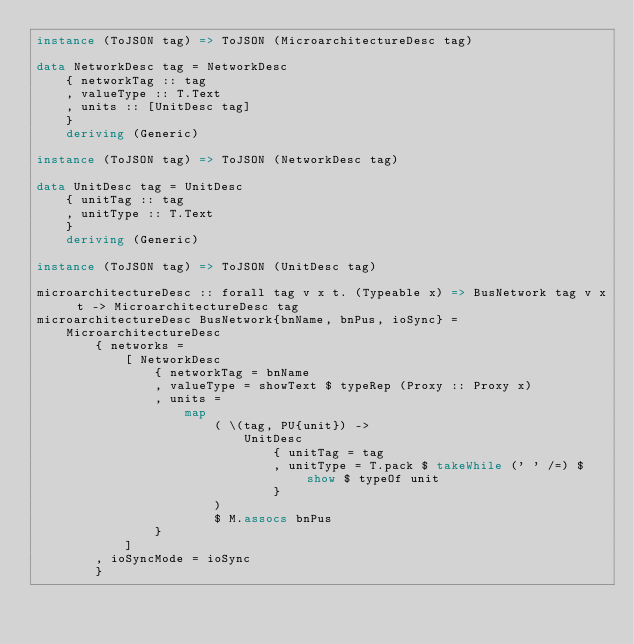<code> <loc_0><loc_0><loc_500><loc_500><_Haskell_>instance (ToJSON tag) => ToJSON (MicroarchitectureDesc tag)

data NetworkDesc tag = NetworkDesc
    { networkTag :: tag
    , valueType :: T.Text
    , units :: [UnitDesc tag]
    }
    deriving (Generic)

instance (ToJSON tag) => ToJSON (NetworkDesc tag)

data UnitDesc tag = UnitDesc
    { unitTag :: tag
    , unitType :: T.Text
    }
    deriving (Generic)

instance (ToJSON tag) => ToJSON (UnitDesc tag)

microarchitectureDesc :: forall tag v x t. (Typeable x) => BusNetwork tag v x t -> MicroarchitectureDesc tag
microarchitectureDesc BusNetwork{bnName, bnPus, ioSync} =
    MicroarchitectureDesc
        { networks =
            [ NetworkDesc
                { networkTag = bnName
                , valueType = showText $ typeRep (Proxy :: Proxy x)
                , units =
                    map
                        ( \(tag, PU{unit}) ->
                            UnitDesc
                                { unitTag = tag
                                , unitType = T.pack $ takeWhile (' ' /=) $ show $ typeOf unit
                                }
                        )
                        $ M.assocs bnPus
                }
            ]
        , ioSyncMode = ioSync
        }
</code> 